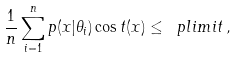Convert formula to latex. <formula><loc_0><loc_0><loc_500><loc_500>\frac { 1 } { n } \sum _ { i = 1 } ^ { n } p ( x | \theta _ { i } ) \cos t ( x ) \leq \ p l i m i t \, ,</formula> 